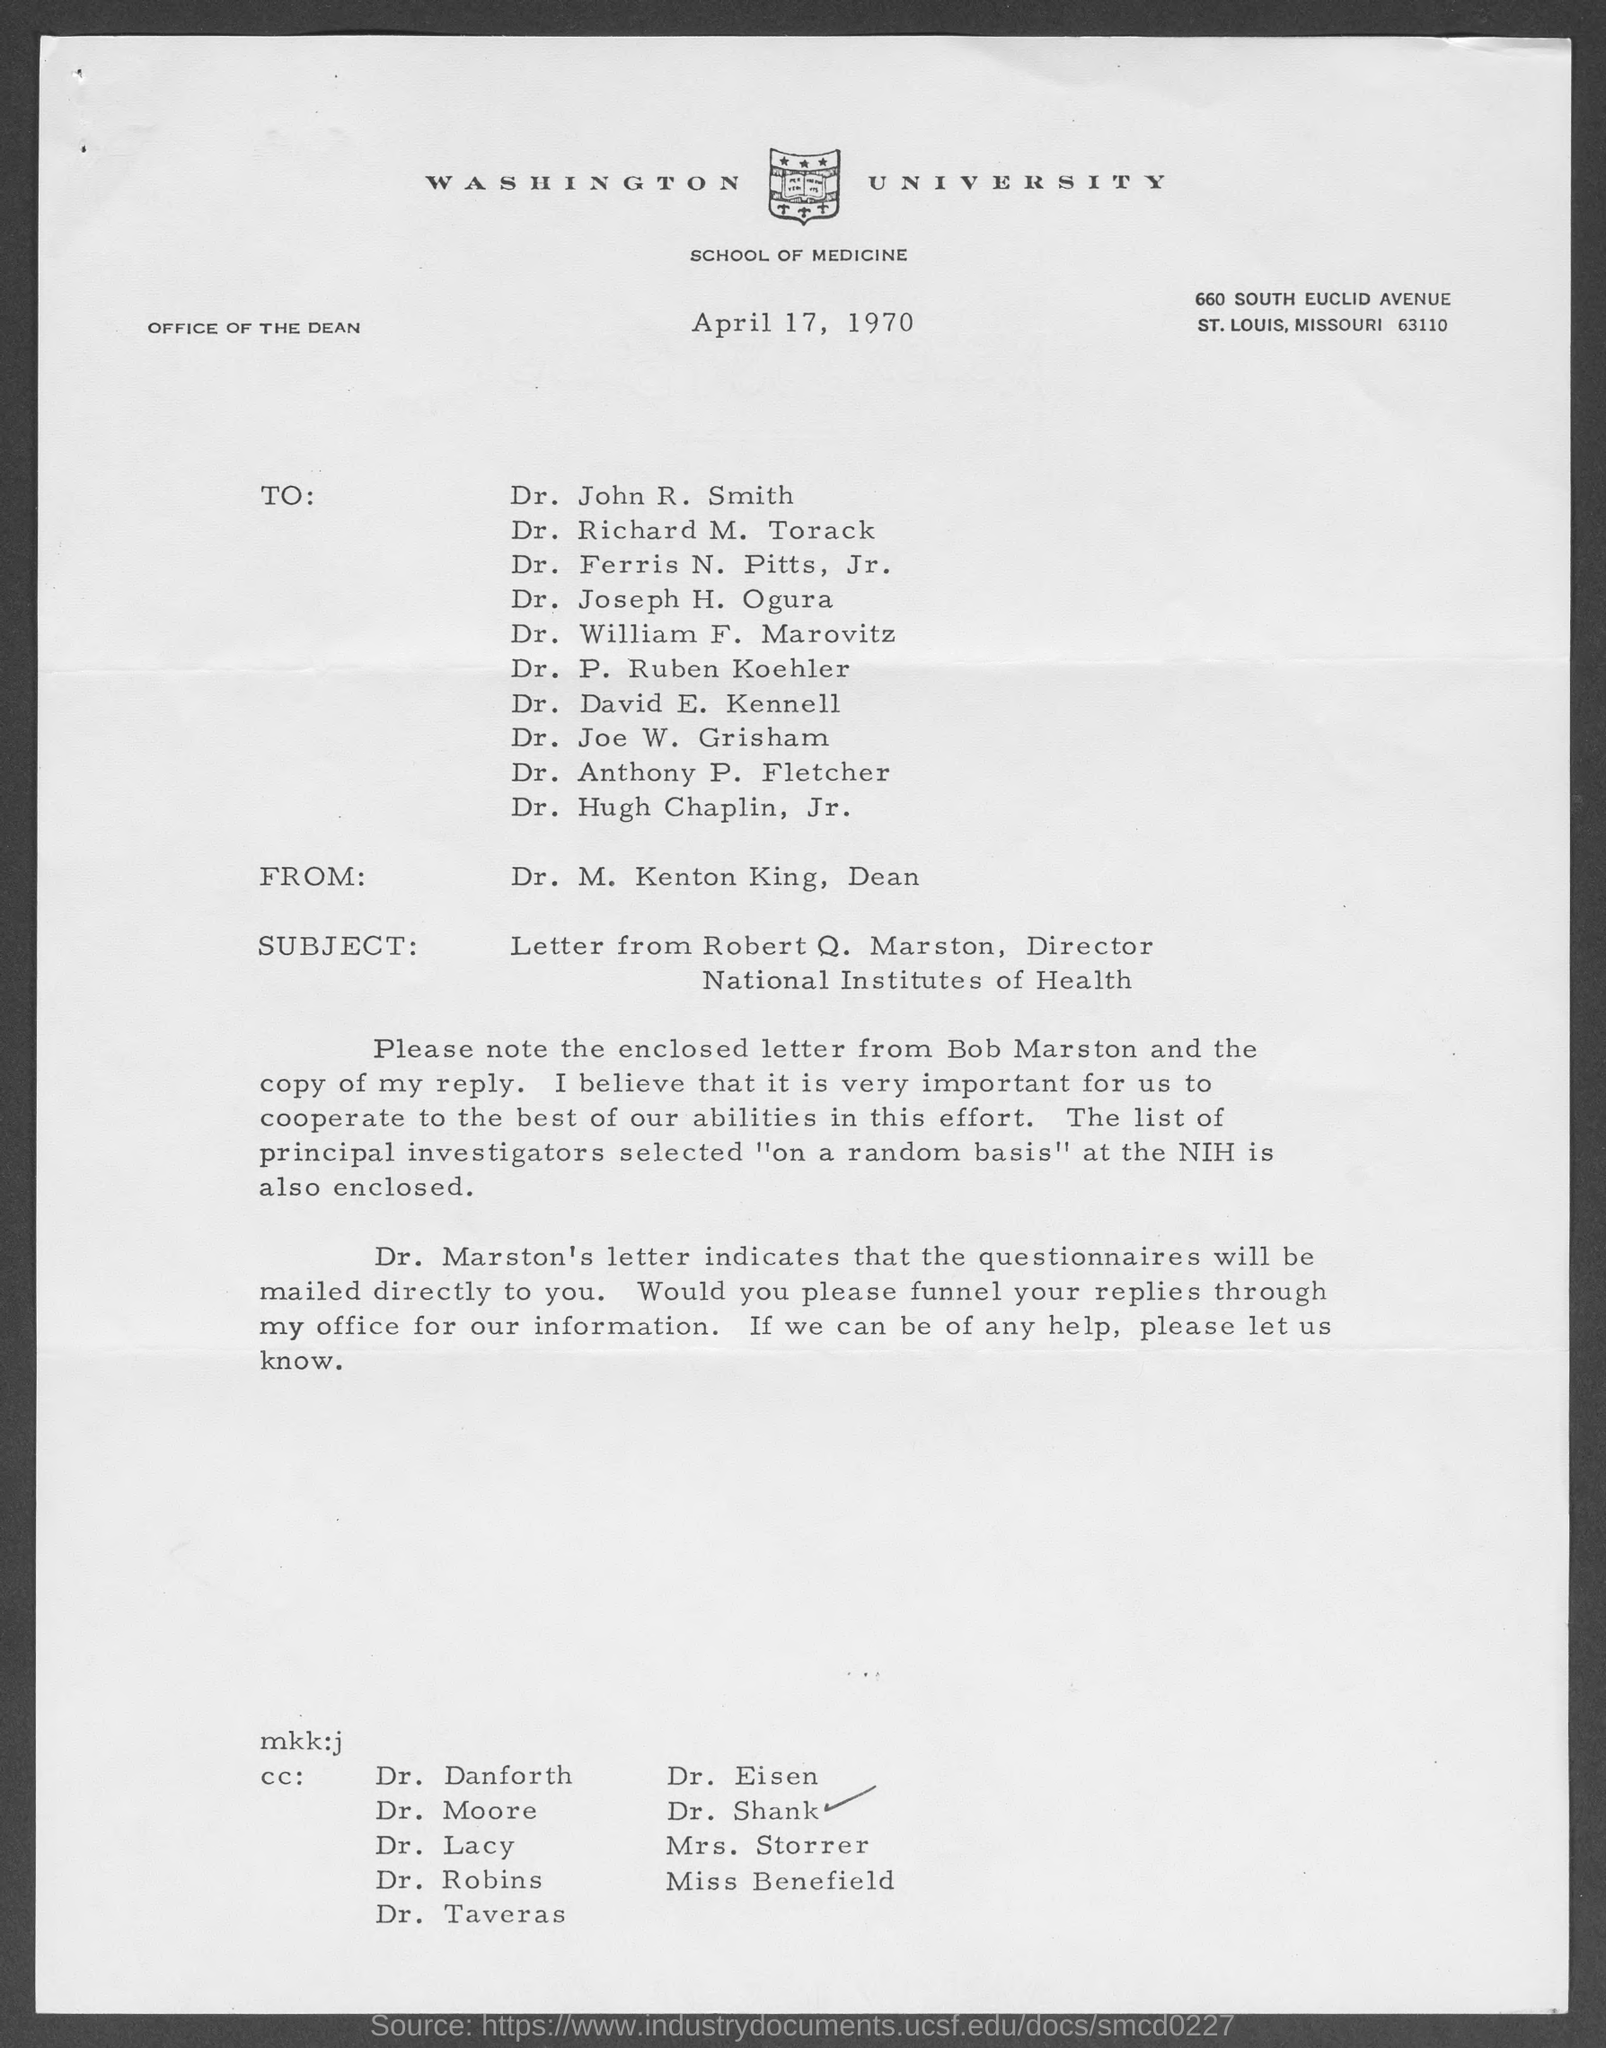Mention a couple of crucial points in this snapshot. The subject mentioned in the letter is the National Institutes of Health. The date mentioned in this letter is April 17, 1970. The letterhead mentions Washington University. 